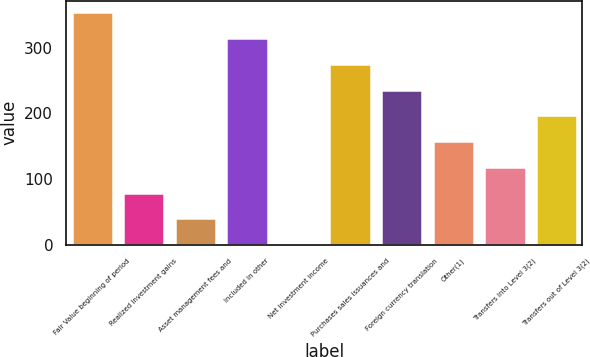Convert chart. <chart><loc_0><loc_0><loc_500><loc_500><bar_chart><fcel>Fair Value beginning of period<fcel>Realized investment gains<fcel>Asset management fees and<fcel>Included in other<fcel>Net investment income<fcel>Purchases sales issuances and<fcel>Foreign currency translation<fcel>Other(1)<fcel>Transfers into Level 3(2)<fcel>Transfers out of Level 3(2)<nl><fcel>353.73<fcel>79.05<fcel>39.81<fcel>314.49<fcel>0.57<fcel>275.25<fcel>236.01<fcel>157.53<fcel>118.29<fcel>196.77<nl></chart> 